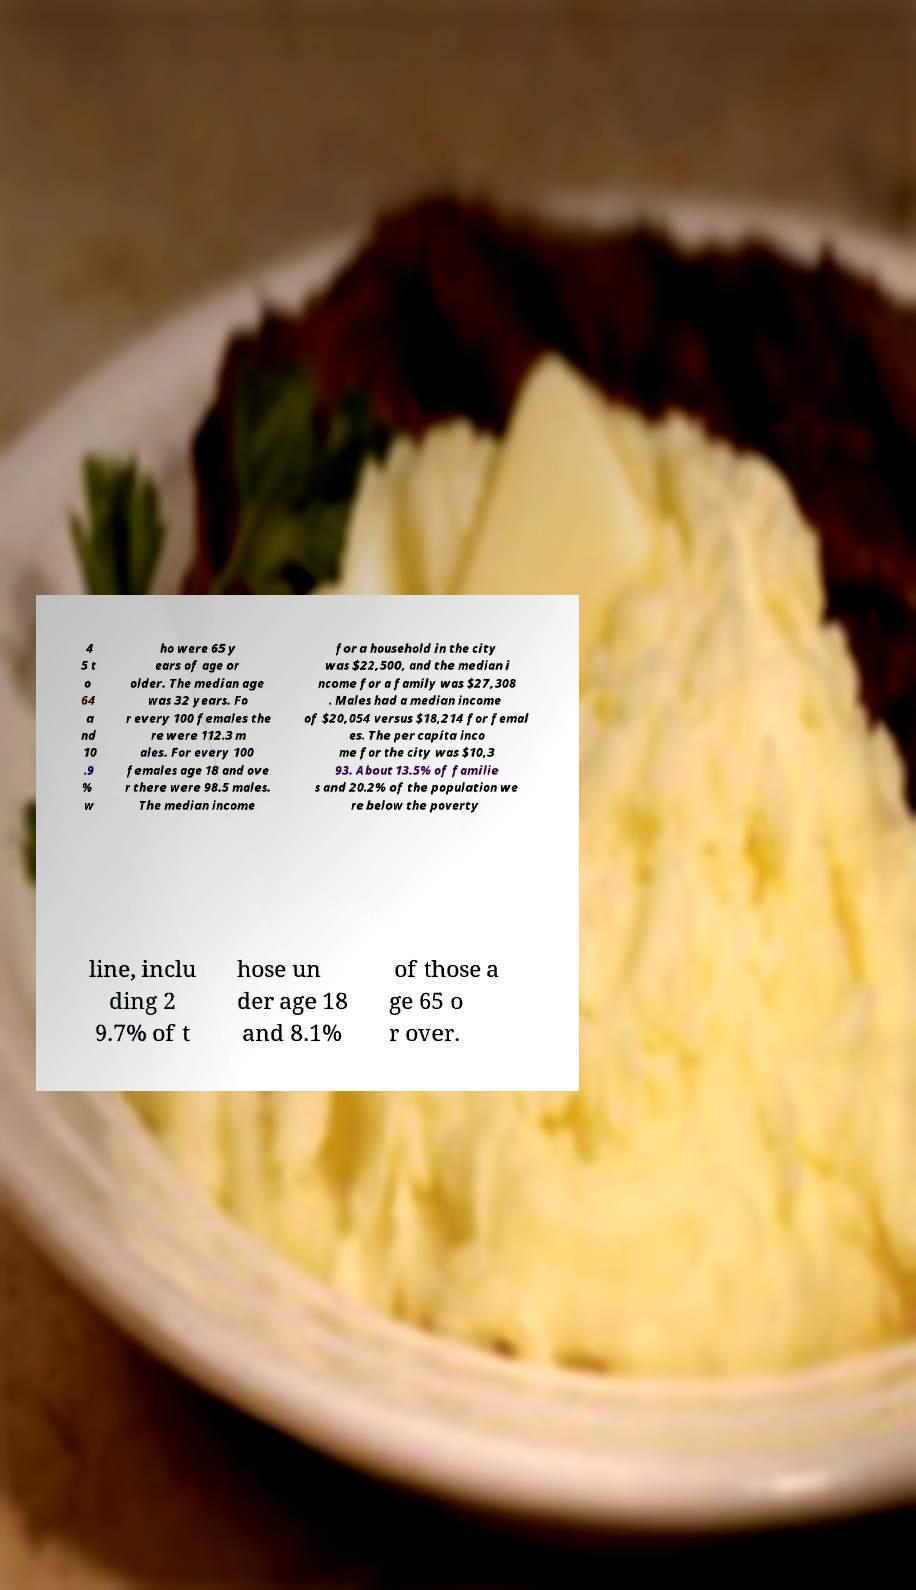Can you accurately transcribe the text from the provided image for me? 4 5 t o 64 a nd 10 .9 % w ho were 65 y ears of age or older. The median age was 32 years. Fo r every 100 females the re were 112.3 m ales. For every 100 females age 18 and ove r there were 98.5 males. The median income for a household in the city was $22,500, and the median i ncome for a family was $27,308 . Males had a median income of $20,054 versus $18,214 for femal es. The per capita inco me for the city was $10,3 93. About 13.5% of familie s and 20.2% of the population we re below the poverty line, inclu ding 2 9.7% of t hose un der age 18 and 8.1% of those a ge 65 o r over. 